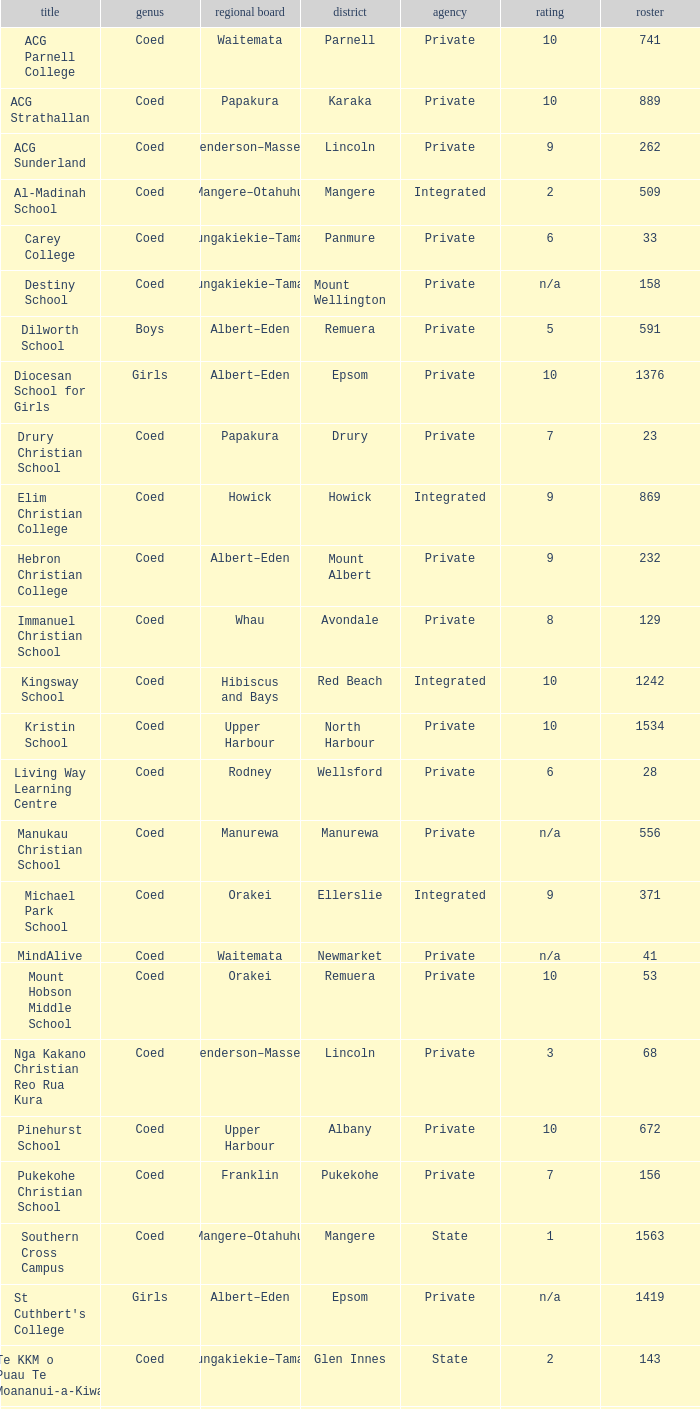What gender has a local board of albert–eden with a roll of more than 232 and Decile of 5? Boys. 